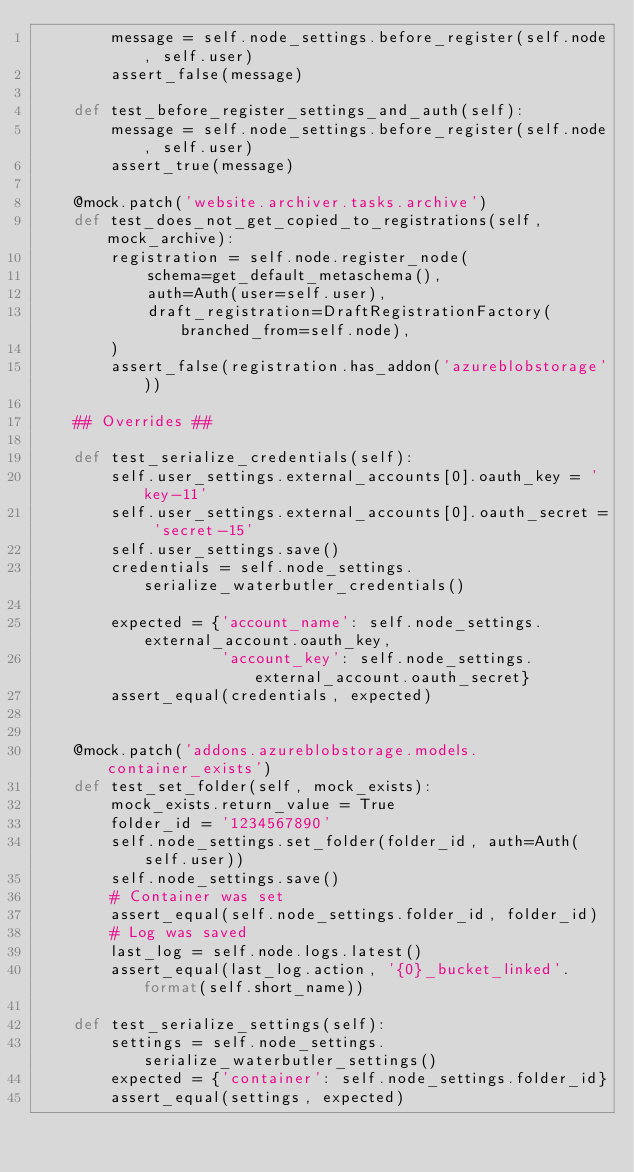Convert code to text. <code><loc_0><loc_0><loc_500><loc_500><_Python_>        message = self.node_settings.before_register(self.node, self.user)
        assert_false(message)

    def test_before_register_settings_and_auth(self):
        message = self.node_settings.before_register(self.node, self.user)
        assert_true(message)

    @mock.patch('website.archiver.tasks.archive')
    def test_does_not_get_copied_to_registrations(self, mock_archive):
        registration = self.node.register_node(
            schema=get_default_metaschema(),
            auth=Auth(user=self.user),
            draft_registration=DraftRegistrationFactory(branched_from=self.node),
        )
        assert_false(registration.has_addon('azureblobstorage'))

    ## Overrides ##

    def test_serialize_credentials(self):
        self.user_settings.external_accounts[0].oauth_key = 'key-11'
        self.user_settings.external_accounts[0].oauth_secret = 'secret-15'
        self.user_settings.save()
        credentials = self.node_settings.serialize_waterbutler_credentials()

        expected = {'account_name': self.node_settings.external_account.oauth_key,
                    'account_key': self.node_settings.external_account.oauth_secret}
        assert_equal(credentials, expected)


    @mock.patch('addons.azureblobstorage.models.container_exists')
    def test_set_folder(self, mock_exists):
        mock_exists.return_value = True
        folder_id = '1234567890'
        self.node_settings.set_folder(folder_id, auth=Auth(self.user))
        self.node_settings.save()
        # Container was set
        assert_equal(self.node_settings.folder_id, folder_id)
        # Log was saved
        last_log = self.node.logs.latest()
        assert_equal(last_log.action, '{0}_bucket_linked'.format(self.short_name))

    def test_serialize_settings(self):
        settings = self.node_settings.serialize_waterbutler_settings()
        expected = {'container': self.node_settings.folder_id}
        assert_equal(settings, expected)
</code> 